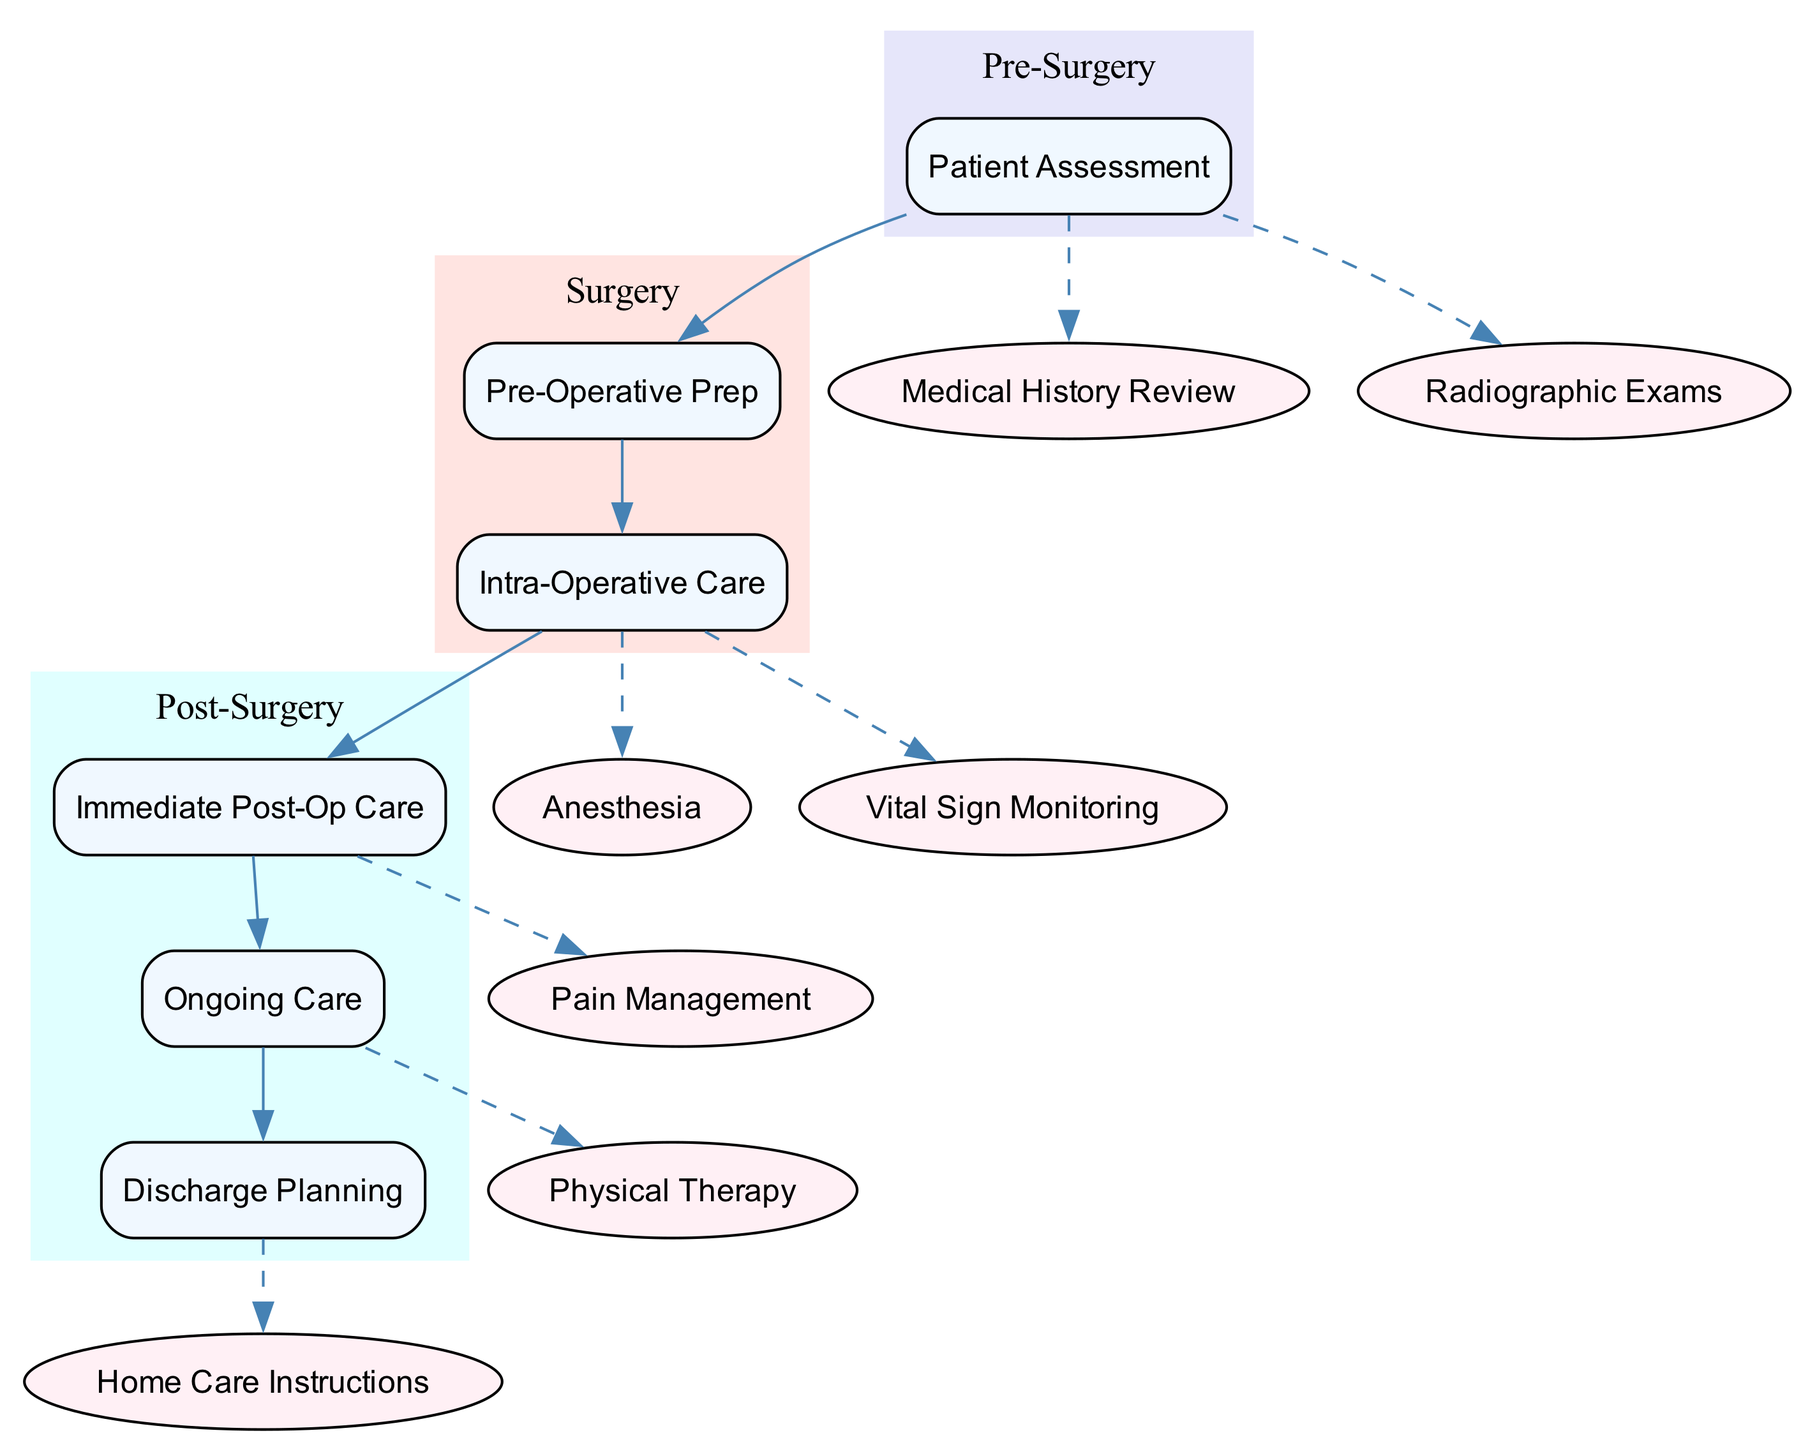What are the two main categories of care in the post-surgery phase? In the post-surgery phase, there are two main categories of care: immediate post-operative care and ongoing care. These are clearly separated in the diagram under the "Post-Surgery" section.
Answer: immediate post-operative care, ongoing care How many subprocesses are included in the patient assessment phase? The patient assessment phase contains five subprocesses: medical history review, radiographic exams, laboratory tests, patient education, and informed consent. Counting these subprocesses shows there are five distinct elements.
Answer: 5 What follows the intra-operative care stage in the diagram? After the intra-operative care stage, the diagram clearly connects to the immediate post-operative care stage, indicating it is the subsequent step in the clinical pathway.
Answer: immediate post-operative care Which specific type of monitoring occurs during the intra-operative care? The intra-operative care section mentions vital sign monitoring as the type of monitoring, indicated as a subprocess connected with a dashed line.
Answer: Vital sign monitoring What is required before surgery according to the diagram? The pre-operative preparation stage specifies several requirements before surgery, including fasting guidelines, pre-medications, and assessment checks, which collectively are critical preparatory steps.
Answer: fasting guidelines, pre-medications, assessment checks Which part of the post-surgery phase contains instructions on home care? The discharge planning section under post-surgery includes home care instructions as a subprocess, highlighting the necessary follow-up care to be provided to the patient going home.
Answer: Home care instructions What should be monitored immediately after surgery? The immediate post-operative care section indicates vital signs, consciousness level, and pain management as critical parameters to be monitored right after surgery, ensuring patient stability.
Answer: Vital signs, consciousness level, pain management 